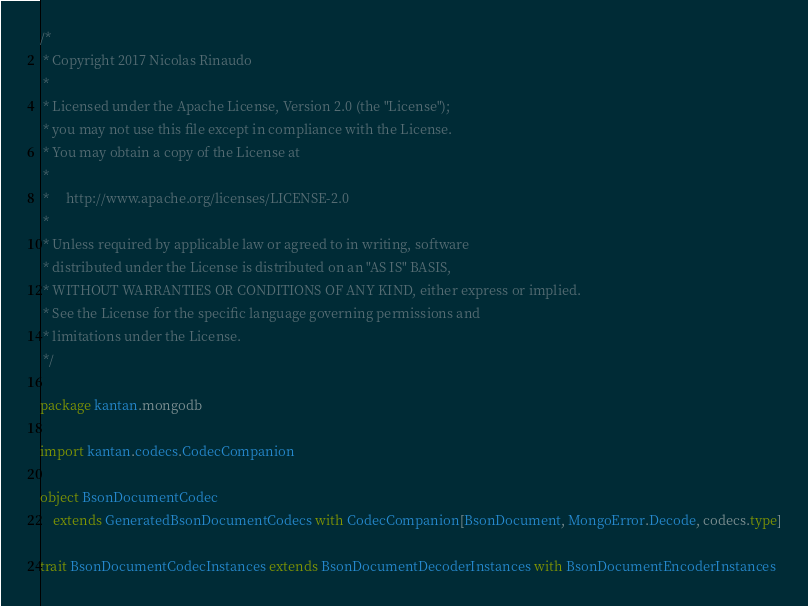Convert code to text. <code><loc_0><loc_0><loc_500><loc_500><_Scala_>/*
 * Copyright 2017 Nicolas Rinaudo
 *
 * Licensed under the Apache License, Version 2.0 (the "License");
 * you may not use this file except in compliance with the License.
 * You may obtain a copy of the License at
 *
 *     http://www.apache.org/licenses/LICENSE-2.0
 *
 * Unless required by applicable law or agreed to in writing, software
 * distributed under the License is distributed on an "AS IS" BASIS,
 * WITHOUT WARRANTIES OR CONDITIONS OF ANY KIND, either express or implied.
 * See the License for the specific language governing permissions and
 * limitations under the License.
 */

package kantan.mongodb

import kantan.codecs.CodecCompanion

object BsonDocumentCodec
    extends GeneratedBsonDocumentCodecs with CodecCompanion[BsonDocument, MongoError.Decode, codecs.type]

trait BsonDocumentCodecInstances extends BsonDocumentDecoderInstances with BsonDocumentEncoderInstances
</code> 